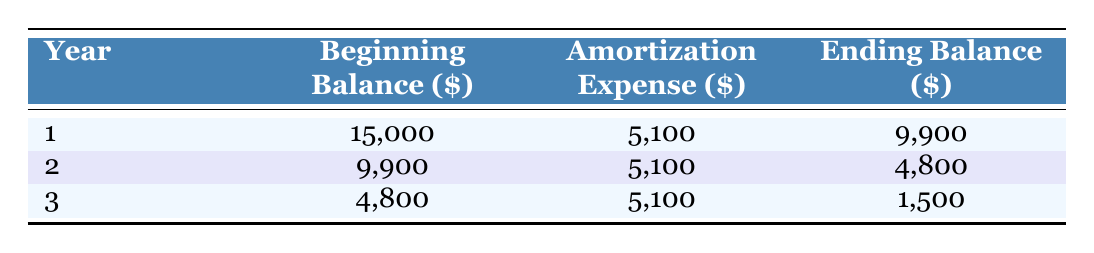What is the initial investment amount? The table lists the initial investment amount at the top, which is shown as fifteen thousand dollars.
Answer: 15000 What is the amortization expense for the second year? According to the table, the amortization expense for the second year is explicitly listed and is five thousand one hundred dollars.
Answer: 5100 What is the ending balance at the end of the third year? The ending balance after the third year can be found in the table under the third year column, which shows a balance of one thousand five hundred dollars.
Answer: 1500 How much total amortization expense is recorded over the three years? The total amortization expense can be calculated by adding the annual amortization for all three years: five thousand one hundred plus five thousand one hundred plus five thousand one hundred equals fifteen thousand three hundred.
Answer: 15300 Is the amortization expense consistent each year? The table indicates that the amortization expense is the same each year, as it shows five thousand one hundred dollars for all three years.
Answer: Yes What is the change in beginning balance from year 1 to year 2? The beginning balance for year 1 is fifteen thousand dollars and for year 2 it is nine thousand nine hundred dollars. To find the change, subtract nine thousand nine hundred from fifteen thousand, which results in a change of five thousand one hundred dollars.
Answer: 5100 How much is the residual value of the investment after the three years? The table states that the residual value after the useful life of three years is one thousand five hundred dollars, which is provided in the initial data.
Answer: 1500 Was the beginning balance for year 2 less than the beginning balance for year 3? By comparing the beginning balances, the beginning balance for year 2 is nine thousand nine hundred dollars and for year 3 it is four thousand eight hundred dollars, which shows that the beginning balance for year 2 is indeed greater.
Answer: No What is the total remaining balance after the three years compared to the initial investment? The remaining balance after the three years is one thousand five hundred dollars, and the initial investment was fifteen thousand dollars. To determine the total difference, subtract one thousand five hundred from fifteen thousand, resulting in a reduction of thirteen thousand five hundred dollars.
Answer: 13500 